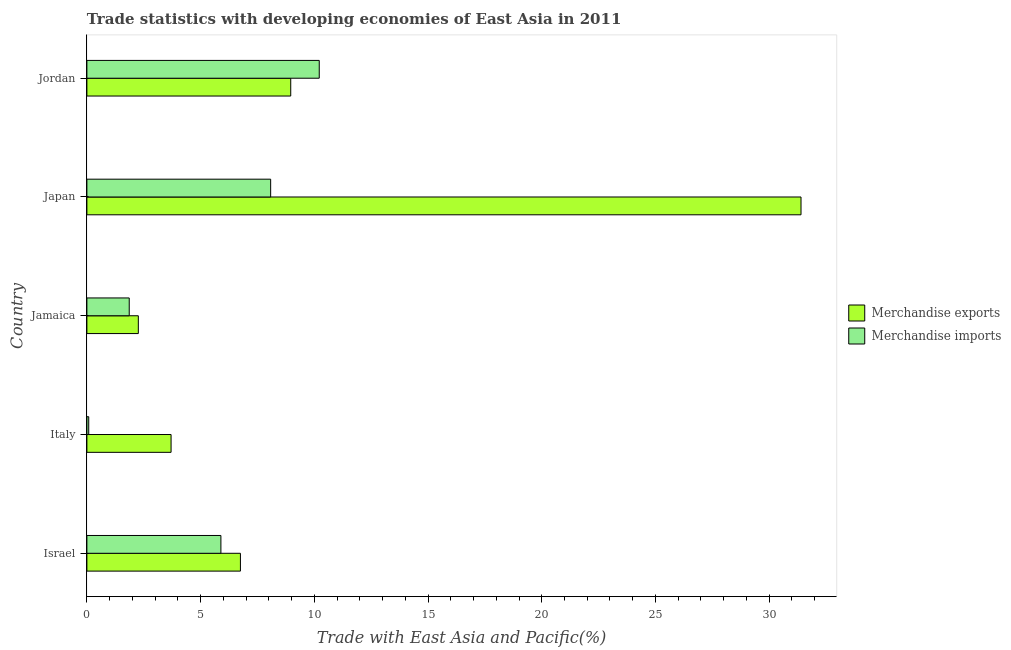How many different coloured bars are there?
Ensure brevity in your answer.  2. Are the number of bars per tick equal to the number of legend labels?
Make the answer very short. Yes. Are the number of bars on each tick of the Y-axis equal?
Ensure brevity in your answer.  Yes. How many bars are there on the 2nd tick from the bottom?
Your answer should be very brief. 2. What is the label of the 5th group of bars from the top?
Your answer should be compact. Israel. What is the merchandise imports in Italy?
Provide a succinct answer. 0.08. Across all countries, what is the maximum merchandise imports?
Your answer should be very brief. 10.22. Across all countries, what is the minimum merchandise exports?
Give a very brief answer. 2.26. In which country was the merchandise imports maximum?
Provide a succinct answer. Jordan. In which country was the merchandise exports minimum?
Offer a terse response. Jamaica. What is the total merchandise exports in the graph?
Your response must be concise. 53.08. What is the difference between the merchandise exports in Italy and that in Jamaica?
Provide a succinct answer. 1.44. What is the difference between the merchandise imports in Japan and the merchandise exports in Israel?
Make the answer very short. 1.33. What is the average merchandise exports per country?
Ensure brevity in your answer.  10.62. What is the difference between the merchandise exports and merchandise imports in Jamaica?
Offer a terse response. 0.4. In how many countries, is the merchandise imports greater than 27 %?
Offer a very short reply. 0. What is the ratio of the merchandise imports in Israel to that in Jamaica?
Your answer should be compact. 3.17. Is the merchandise exports in Italy less than that in Jamaica?
Keep it short and to the point. No. Is the difference between the merchandise imports in Israel and Italy greater than the difference between the merchandise exports in Israel and Italy?
Make the answer very short. Yes. What is the difference between the highest and the second highest merchandise exports?
Provide a short and direct response. 22.44. What is the difference between the highest and the lowest merchandise exports?
Your response must be concise. 29.14. In how many countries, is the merchandise imports greater than the average merchandise imports taken over all countries?
Make the answer very short. 3. What does the 2nd bar from the top in Jamaica represents?
Provide a short and direct response. Merchandise exports. What does the 2nd bar from the bottom in Italy represents?
Make the answer very short. Merchandise imports. What is the difference between two consecutive major ticks on the X-axis?
Make the answer very short. 5. Does the graph contain any zero values?
Make the answer very short. No. Does the graph contain grids?
Your answer should be compact. No. Where does the legend appear in the graph?
Offer a very short reply. Center right. How many legend labels are there?
Make the answer very short. 2. What is the title of the graph?
Ensure brevity in your answer.  Trade statistics with developing economies of East Asia in 2011. What is the label or title of the X-axis?
Your answer should be compact. Trade with East Asia and Pacific(%). What is the label or title of the Y-axis?
Offer a terse response. Country. What is the Trade with East Asia and Pacific(%) of Merchandise exports in Israel?
Keep it short and to the point. 6.75. What is the Trade with East Asia and Pacific(%) in Merchandise imports in Israel?
Keep it short and to the point. 5.89. What is the Trade with East Asia and Pacific(%) of Merchandise exports in Italy?
Your response must be concise. 3.7. What is the Trade with East Asia and Pacific(%) in Merchandise imports in Italy?
Your response must be concise. 0.08. What is the Trade with East Asia and Pacific(%) of Merchandise exports in Jamaica?
Keep it short and to the point. 2.26. What is the Trade with East Asia and Pacific(%) of Merchandise imports in Jamaica?
Provide a short and direct response. 1.86. What is the Trade with East Asia and Pacific(%) in Merchandise exports in Japan?
Make the answer very short. 31.4. What is the Trade with East Asia and Pacific(%) in Merchandise imports in Japan?
Ensure brevity in your answer.  8.08. What is the Trade with East Asia and Pacific(%) in Merchandise exports in Jordan?
Offer a very short reply. 8.96. What is the Trade with East Asia and Pacific(%) of Merchandise imports in Jordan?
Offer a very short reply. 10.22. Across all countries, what is the maximum Trade with East Asia and Pacific(%) of Merchandise exports?
Ensure brevity in your answer.  31.4. Across all countries, what is the maximum Trade with East Asia and Pacific(%) in Merchandise imports?
Keep it short and to the point. 10.22. Across all countries, what is the minimum Trade with East Asia and Pacific(%) in Merchandise exports?
Your answer should be very brief. 2.26. Across all countries, what is the minimum Trade with East Asia and Pacific(%) of Merchandise imports?
Provide a short and direct response. 0.08. What is the total Trade with East Asia and Pacific(%) in Merchandise exports in the graph?
Your response must be concise. 53.08. What is the total Trade with East Asia and Pacific(%) in Merchandise imports in the graph?
Provide a short and direct response. 26.13. What is the difference between the Trade with East Asia and Pacific(%) in Merchandise exports in Israel and that in Italy?
Provide a short and direct response. 3.05. What is the difference between the Trade with East Asia and Pacific(%) in Merchandise imports in Israel and that in Italy?
Offer a very short reply. 5.81. What is the difference between the Trade with East Asia and Pacific(%) of Merchandise exports in Israel and that in Jamaica?
Your answer should be compact. 4.49. What is the difference between the Trade with East Asia and Pacific(%) in Merchandise imports in Israel and that in Jamaica?
Offer a very short reply. 4.03. What is the difference between the Trade with East Asia and Pacific(%) in Merchandise exports in Israel and that in Japan?
Provide a succinct answer. -24.65. What is the difference between the Trade with East Asia and Pacific(%) in Merchandise imports in Israel and that in Japan?
Offer a terse response. -2.19. What is the difference between the Trade with East Asia and Pacific(%) in Merchandise exports in Israel and that in Jordan?
Your answer should be compact. -2.21. What is the difference between the Trade with East Asia and Pacific(%) of Merchandise imports in Israel and that in Jordan?
Give a very brief answer. -4.32. What is the difference between the Trade with East Asia and Pacific(%) in Merchandise exports in Italy and that in Jamaica?
Keep it short and to the point. 1.44. What is the difference between the Trade with East Asia and Pacific(%) of Merchandise imports in Italy and that in Jamaica?
Offer a very short reply. -1.78. What is the difference between the Trade with East Asia and Pacific(%) of Merchandise exports in Italy and that in Japan?
Your answer should be very brief. -27.7. What is the difference between the Trade with East Asia and Pacific(%) in Merchandise imports in Italy and that in Japan?
Provide a succinct answer. -8. What is the difference between the Trade with East Asia and Pacific(%) of Merchandise exports in Italy and that in Jordan?
Provide a short and direct response. -5.26. What is the difference between the Trade with East Asia and Pacific(%) in Merchandise imports in Italy and that in Jordan?
Provide a short and direct response. -10.14. What is the difference between the Trade with East Asia and Pacific(%) of Merchandise exports in Jamaica and that in Japan?
Give a very brief answer. -29.14. What is the difference between the Trade with East Asia and Pacific(%) of Merchandise imports in Jamaica and that in Japan?
Make the answer very short. -6.22. What is the difference between the Trade with East Asia and Pacific(%) in Merchandise exports in Jamaica and that in Jordan?
Offer a very short reply. -6.7. What is the difference between the Trade with East Asia and Pacific(%) in Merchandise imports in Jamaica and that in Jordan?
Offer a terse response. -8.35. What is the difference between the Trade with East Asia and Pacific(%) of Merchandise exports in Japan and that in Jordan?
Provide a short and direct response. 22.44. What is the difference between the Trade with East Asia and Pacific(%) in Merchandise imports in Japan and that in Jordan?
Make the answer very short. -2.14. What is the difference between the Trade with East Asia and Pacific(%) of Merchandise exports in Israel and the Trade with East Asia and Pacific(%) of Merchandise imports in Italy?
Keep it short and to the point. 6.67. What is the difference between the Trade with East Asia and Pacific(%) in Merchandise exports in Israel and the Trade with East Asia and Pacific(%) in Merchandise imports in Jamaica?
Offer a very short reply. 4.89. What is the difference between the Trade with East Asia and Pacific(%) of Merchandise exports in Israel and the Trade with East Asia and Pacific(%) of Merchandise imports in Japan?
Keep it short and to the point. -1.33. What is the difference between the Trade with East Asia and Pacific(%) in Merchandise exports in Israel and the Trade with East Asia and Pacific(%) in Merchandise imports in Jordan?
Keep it short and to the point. -3.47. What is the difference between the Trade with East Asia and Pacific(%) of Merchandise exports in Italy and the Trade with East Asia and Pacific(%) of Merchandise imports in Jamaica?
Provide a succinct answer. 1.84. What is the difference between the Trade with East Asia and Pacific(%) in Merchandise exports in Italy and the Trade with East Asia and Pacific(%) in Merchandise imports in Japan?
Offer a very short reply. -4.38. What is the difference between the Trade with East Asia and Pacific(%) of Merchandise exports in Italy and the Trade with East Asia and Pacific(%) of Merchandise imports in Jordan?
Offer a terse response. -6.51. What is the difference between the Trade with East Asia and Pacific(%) in Merchandise exports in Jamaica and the Trade with East Asia and Pacific(%) in Merchandise imports in Japan?
Provide a succinct answer. -5.82. What is the difference between the Trade with East Asia and Pacific(%) of Merchandise exports in Jamaica and the Trade with East Asia and Pacific(%) of Merchandise imports in Jordan?
Make the answer very short. -7.95. What is the difference between the Trade with East Asia and Pacific(%) of Merchandise exports in Japan and the Trade with East Asia and Pacific(%) of Merchandise imports in Jordan?
Provide a succinct answer. 21.18. What is the average Trade with East Asia and Pacific(%) of Merchandise exports per country?
Ensure brevity in your answer.  10.62. What is the average Trade with East Asia and Pacific(%) of Merchandise imports per country?
Keep it short and to the point. 5.23. What is the difference between the Trade with East Asia and Pacific(%) in Merchandise exports and Trade with East Asia and Pacific(%) in Merchandise imports in Israel?
Ensure brevity in your answer.  0.86. What is the difference between the Trade with East Asia and Pacific(%) of Merchandise exports and Trade with East Asia and Pacific(%) of Merchandise imports in Italy?
Your answer should be compact. 3.62. What is the difference between the Trade with East Asia and Pacific(%) of Merchandise exports and Trade with East Asia and Pacific(%) of Merchandise imports in Jamaica?
Your response must be concise. 0.4. What is the difference between the Trade with East Asia and Pacific(%) in Merchandise exports and Trade with East Asia and Pacific(%) in Merchandise imports in Japan?
Offer a terse response. 23.32. What is the difference between the Trade with East Asia and Pacific(%) in Merchandise exports and Trade with East Asia and Pacific(%) in Merchandise imports in Jordan?
Offer a terse response. -1.25. What is the ratio of the Trade with East Asia and Pacific(%) of Merchandise exports in Israel to that in Italy?
Keep it short and to the point. 1.82. What is the ratio of the Trade with East Asia and Pacific(%) in Merchandise imports in Israel to that in Italy?
Your response must be concise. 73.1. What is the ratio of the Trade with East Asia and Pacific(%) in Merchandise exports in Israel to that in Jamaica?
Keep it short and to the point. 2.98. What is the ratio of the Trade with East Asia and Pacific(%) in Merchandise imports in Israel to that in Jamaica?
Your answer should be very brief. 3.17. What is the ratio of the Trade with East Asia and Pacific(%) in Merchandise exports in Israel to that in Japan?
Provide a short and direct response. 0.21. What is the ratio of the Trade with East Asia and Pacific(%) of Merchandise imports in Israel to that in Japan?
Make the answer very short. 0.73. What is the ratio of the Trade with East Asia and Pacific(%) in Merchandise exports in Israel to that in Jordan?
Offer a very short reply. 0.75. What is the ratio of the Trade with East Asia and Pacific(%) in Merchandise imports in Israel to that in Jordan?
Offer a very short reply. 0.58. What is the ratio of the Trade with East Asia and Pacific(%) in Merchandise exports in Italy to that in Jamaica?
Offer a terse response. 1.64. What is the ratio of the Trade with East Asia and Pacific(%) of Merchandise imports in Italy to that in Jamaica?
Make the answer very short. 0.04. What is the ratio of the Trade with East Asia and Pacific(%) of Merchandise exports in Italy to that in Japan?
Provide a succinct answer. 0.12. What is the ratio of the Trade with East Asia and Pacific(%) of Merchandise imports in Italy to that in Japan?
Make the answer very short. 0.01. What is the ratio of the Trade with East Asia and Pacific(%) in Merchandise exports in Italy to that in Jordan?
Give a very brief answer. 0.41. What is the ratio of the Trade with East Asia and Pacific(%) in Merchandise imports in Italy to that in Jordan?
Make the answer very short. 0.01. What is the ratio of the Trade with East Asia and Pacific(%) of Merchandise exports in Jamaica to that in Japan?
Offer a very short reply. 0.07. What is the ratio of the Trade with East Asia and Pacific(%) of Merchandise imports in Jamaica to that in Japan?
Your answer should be very brief. 0.23. What is the ratio of the Trade with East Asia and Pacific(%) of Merchandise exports in Jamaica to that in Jordan?
Your answer should be compact. 0.25. What is the ratio of the Trade with East Asia and Pacific(%) of Merchandise imports in Jamaica to that in Jordan?
Offer a very short reply. 0.18. What is the ratio of the Trade with East Asia and Pacific(%) of Merchandise exports in Japan to that in Jordan?
Your answer should be very brief. 3.5. What is the ratio of the Trade with East Asia and Pacific(%) of Merchandise imports in Japan to that in Jordan?
Give a very brief answer. 0.79. What is the difference between the highest and the second highest Trade with East Asia and Pacific(%) of Merchandise exports?
Ensure brevity in your answer.  22.44. What is the difference between the highest and the second highest Trade with East Asia and Pacific(%) in Merchandise imports?
Your response must be concise. 2.14. What is the difference between the highest and the lowest Trade with East Asia and Pacific(%) of Merchandise exports?
Keep it short and to the point. 29.14. What is the difference between the highest and the lowest Trade with East Asia and Pacific(%) in Merchandise imports?
Keep it short and to the point. 10.14. 